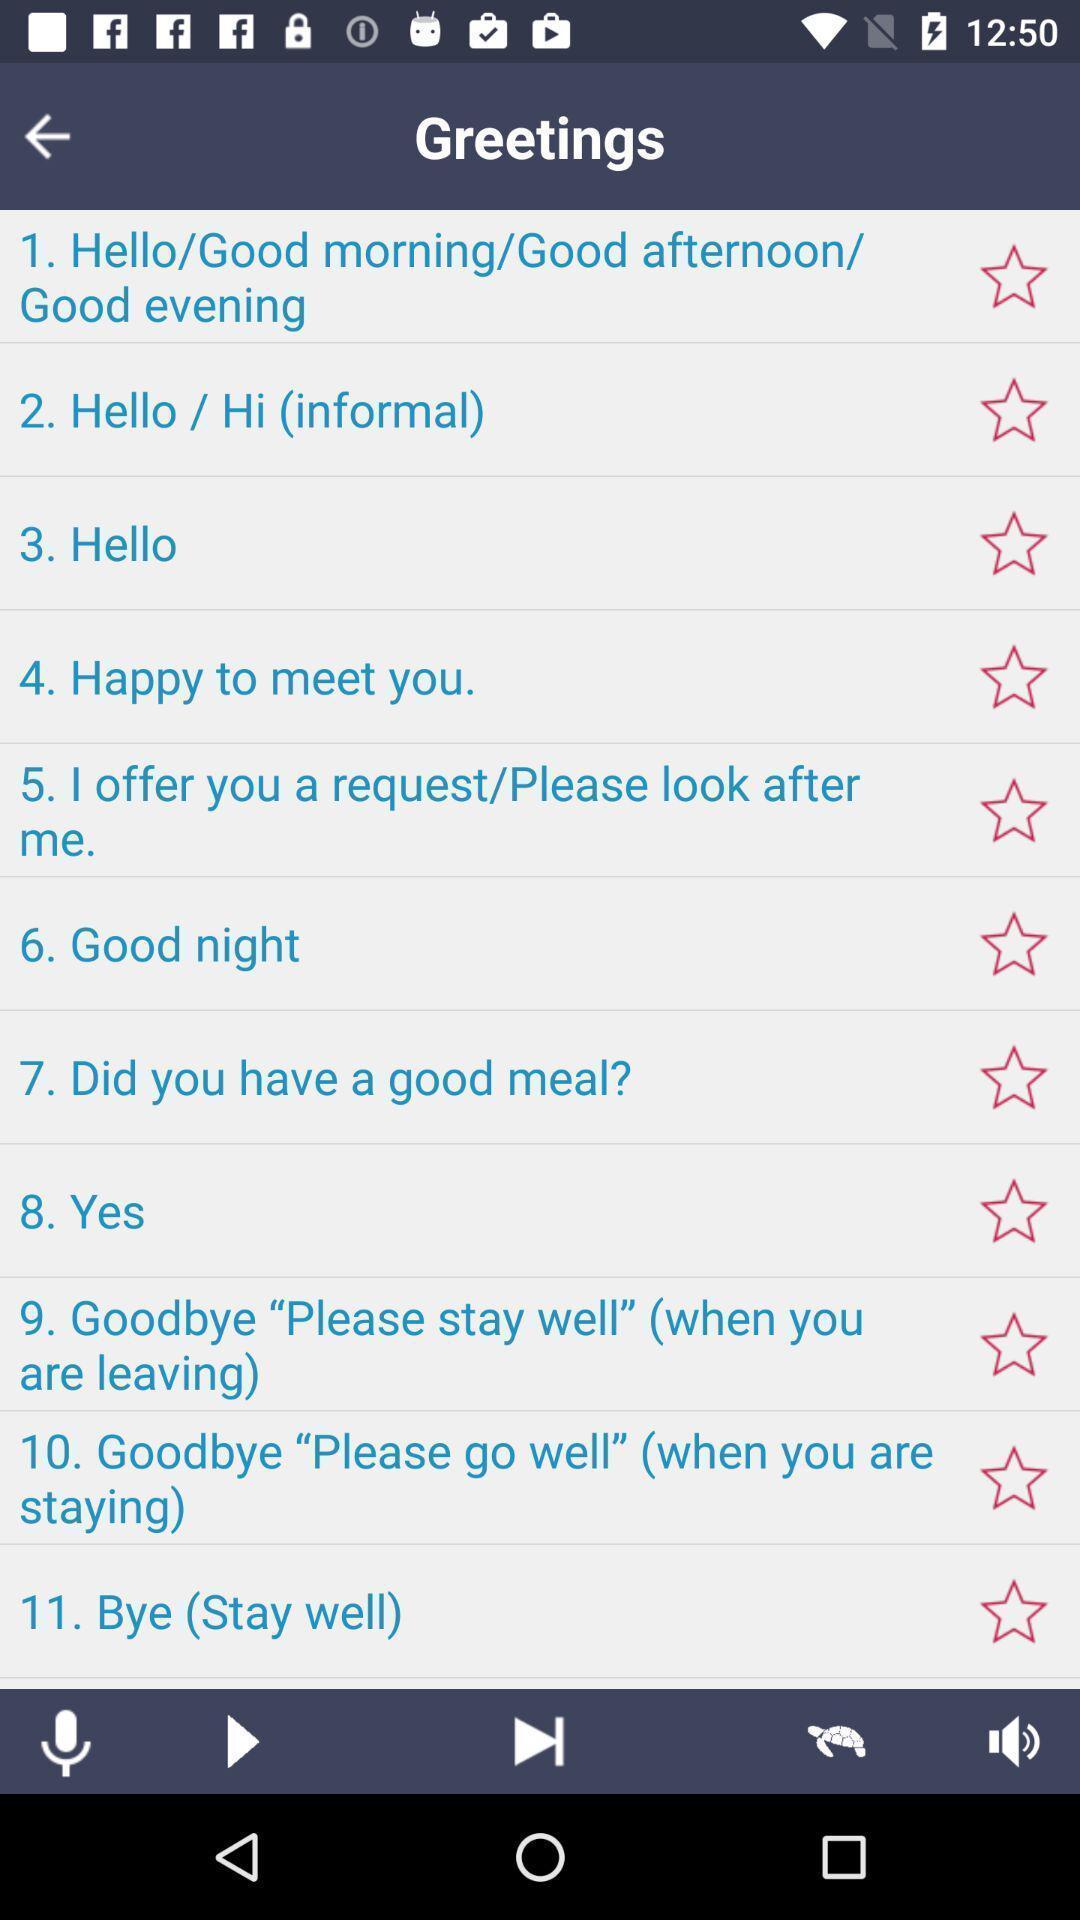Provide a detailed account of this screenshot. Screen displaying list of messages. 